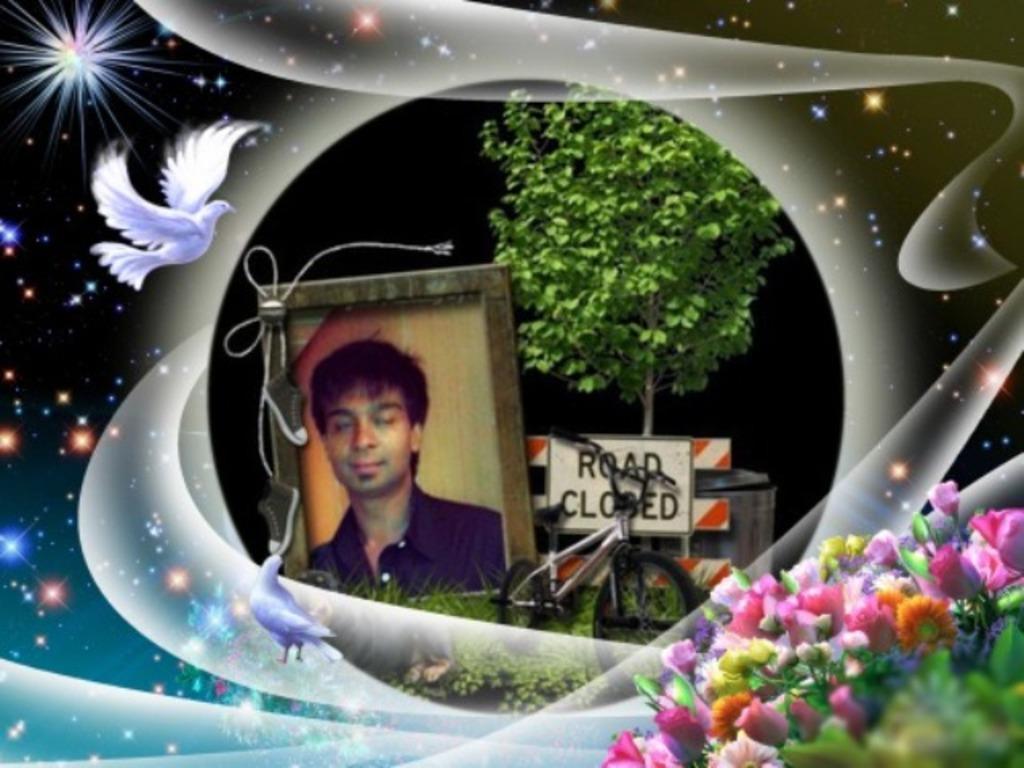Describe this image in one or two sentences. This picture is an edited picture. In this picture there is a picture of a person in the frame and there is a bicycle and there is a board and tree. At the bottom right there are flowers. On the left side of the image there are birds. At the back there are stars. 